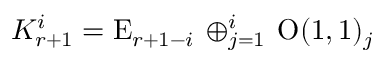Convert formula to latex. <formula><loc_0><loc_0><loc_500><loc_500>K _ { r + 1 } ^ { i } = E _ { r + 1 - i } \, \oplus _ { j = 1 } ^ { i } \, O ( 1 , 1 ) _ { j }</formula> 